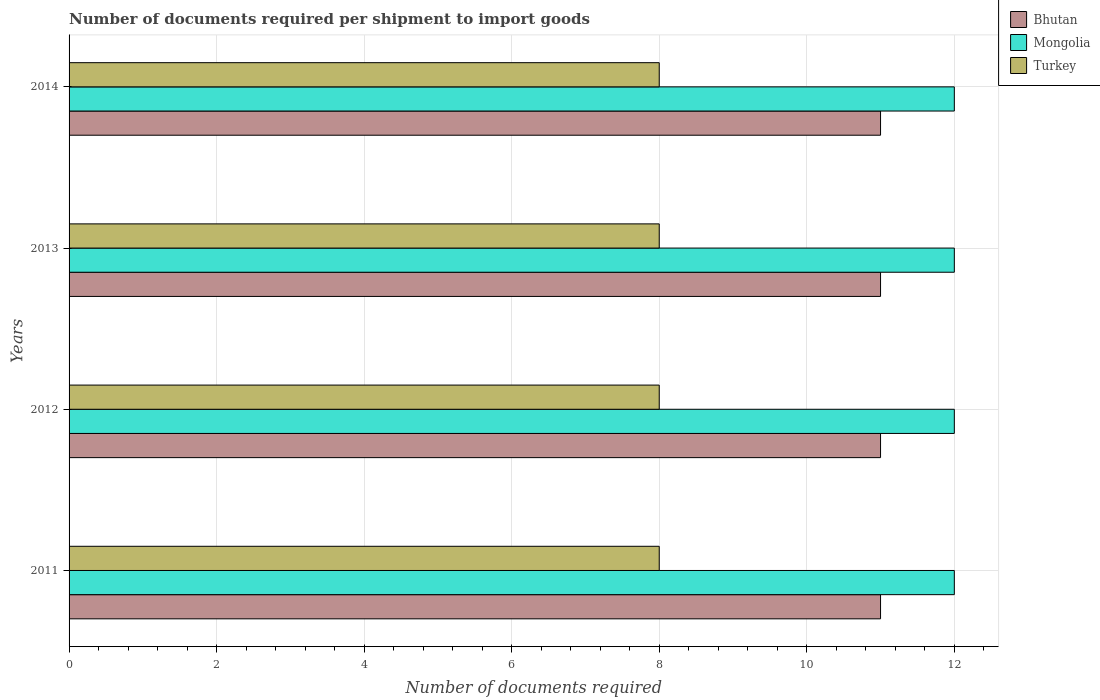How many groups of bars are there?
Keep it short and to the point. 4. Are the number of bars on each tick of the Y-axis equal?
Give a very brief answer. Yes. In how many cases, is the number of bars for a given year not equal to the number of legend labels?
Offer a very short reply. 0. What is the number of documents required per shipment to import goods in Turkey in 2012?
Provide a short and direct response. 8. Across all years, what is the maximum number of documents required per shipment to import goods in Bhutan?
Make the answer very short. 11. Across all years, what is the minimum number of documents required per shipment to import goods in Bhutan?
Give a very brief answer. 11. In which year was the number of documents required per shipment to import goods in Bhutan minimum?
Your answer should be compact. 2011. What is the total number of documents required per shipment to import goods in Bhutan in the graph?
Provide a short and direct response. 44. What is the difference between the number of documents required per shipment to import goods in Bhutan in 2013 and that in 2014?
Keep it short and to the point. 0. What is the difference between the number of documents required per shipment to import goods in Bhutan in 2014 and the number of documents required per shipment to import goods in Turkey in 2012?
Your answer should be compact. 3. In the year 2012, what is the difference between the number of documents required per shipment to import goods in Turkey and number of documents required per shipment to import goods in Bhutan?
Give a very brief answer. -3. In how many years, is the number of documents required per shipment to import goods in Turkey greater than 3.6 ?
Provide a short and direct response. 4. What is the ratio of the number of documents required per shipment to import goods in Bhutan in 2011 to that in 2012?
Provide a succinct answer. 1. Is the number of documents required per shipment to import goods in Mongolia in 2012 less than that in 2013?
Make the answer very short. No. What is the difference between the highest and the second highest number of documents required per shipment to import goods in Bhutan?
Your answer should be very brief. 0. In how many years, is the number of documents required per shipment to import goods in Mongolia greater than the average number of documents required per shipment to import goods in Mongolia taken over all years?
Ensure brevity in your answer.  0. What does the 1st bar from the top in 2014 represents?
Your response must be concise. Turkey. What does the 3rd bar from the bottom in 2012 represents?
Your response must be concise. Turkey. How many bars are there?
Provide a succinct answer. 12. What is the difference between two consecutive major ticks on the X-axis?
Offer a very short reply. 2. How many legend labels are there?
Provide a short and direct response. 3. How are the legend labels stacked?
Give a very brief answer. Vertical. What is the title of the graph?
Ensure brevity in your answer.  Number of documents required per shipment to import goods. Does "Macao" appear as one of the legend labels in the graph?
Ensure brevity in your answer.  No. What is the label or title of the X-axis?
Give a very brief answer. Number of documents required. What is the Number of documents required in Mongolia in 2011?
Your answer should be compact. 12. What is the Number of documents required in Bhutan in 2012?
Your answer should be very brief. 11. What is the Number of documents required of Mongolia in 2012?
Provide a succinct answer. 12. What is the Number of documents required of Turkey in 2012?
Keep it short and to the point. 8. What is the Number of documents required of Bhutan in 2013?
Keep it short and to the point. 11. What is the Number of documents required in Mongolia in 2013?
Provide a short and direct response. 12. What is the Number of documents required of Mongolia in 2014?
Ensure brevity in your answer.  12. Across all years, what is the maximum Number of documents required in Bhutan?
Provide a short and direct response. 11. Across all years, what is the maximum Number of documents required in Mongolia?
Offer a very short reply. 12. Across all years, what is the minimum Number of documents required in Bhutan?
Provide a succinct answer. 11. What is the total Number of documents required in Bhutan in the graph?
Ensure brevity in your answer.  44. What is the total Number of documents required of Turkey in the graph?
Give a very brief answer. 32. What is the difference between the Number of documents required in Mongolia in 2011 and that in 2012?
Make the answer very short. 0. What is the difference between the Number of documents required of Turkey in 2011 and that in 2012?
Offer a terse response. 0. What is the difference between the Number of documents required of Mongolia in 2011 and that in 2014?
Make the answer very short. 0. What is the difference between the Number of documents required of Turkey in 2011 and that in 2014?
Keep it short and to the point. 0. What is the difference between the Number of documents required of Bhutan in 2012 and that in 2013?
Your response must be concise. 0. What is the difference between the Number of documents required of Turkey in 2012 and that in 2013?
Your answer should be very brief. 0. What is the difference between the Number of documents required in Bhutan in 2012 and that in 2014?
Keep it short and to the point. 0. What is the difference between the Number of documents required of Turkey in 2012 and that in 2014?
Your response must be concise. 0. What is the difference between the Number of documents required in Bhutan in 2013 and that in 2014?
Provide a short and direct response. 0. What is the difference between the Number of documents required of Bhutan in 2011 and the Number of documents required of Mongolia in 2012?
Your answer should be very brief. -1. What is the difference between the Number of documents required of Bhutan in 2011 and the Number of documents required of Turkey in 2012?
Offer a terse response. 3. What is the difference between the Number of documents required in Bhutan in 2012 and the Number of documents required in Turkey in 2013?
Your answer should be compact. 3. What is the difference between the Number of documents required in Mongolia in 2012 and the Number of documents required in Turkey in 2013?
Provide a succinct answer. 4. What is the difference between the Number of documents required of Bhutan in 2012 and the Number of documents required of Mongolia in 2014?
Your response must be concise. -1. What is the difference between the Number of documents required in Bhutan in 2013 and the Number of documents required in Turkey in 2014?
Ensure brevity in your answer.  3. What is the average Number of documents required in Bhutan per year?
Provide a short and direct response. 11. What is the average Number of documents required of Turkey per year?
Offer a very short reply. 8. In the year 2012, what is the difference between the Number of documents required in Bhutan and Number of documents required in Mongolia?
Keep it short and to the point. -1. In the year 2012, what is the difference between the Number of documents required of Mongolia and Number of documents required of Turkey?
Your answer should be very brief. 4. In the year 2014, what is the difference between the Number of documents required of Bhutan and Number of documents required of Mongolia?
Your response must be concise. -1. In the year 2014, what is the difference between the Number of documents required of Mongolia and Number of documents required of Turkey?
Ensure brevity in your answer.  4. What is the ratio of the Number of documents required of Bhutan in 2011 to that in 2013?
Your answer should be very brief. 1. What is the ratio of the Number of documents required of Mongolia in 2011 to that in 2013?
Offer a very short reply. 1. What is the ratio of the Number of documents required in Turkey in 2011 to that in 2013?
Keep it short and to the point. 1. What is the ratio of the Number of documents required of Mongolia in 2011 to that in 2014?
Your answer should be very brief. 1. What is the ratio of the Number of documents required of Turkey in 2011 to that in 2014?
Give a very brief answer. 1. What is the ratio of the Number of documents required in Bhutan in 2012 to that in 2013?
Keep it short and to the point. 1. What is the ratio of the Number of documents required in Turkey in 2012 to that in 2013?
Your answer should be very brief. 1. What is the ratio of the Number of documents required of Bhutan in 2012 to that in 2014?
Offer a terse response. 1. What is the ratio of the Number of documents required in Turkey in 2012 to that in 2014?
Provide a short and direct response. 1. What is the ratio of the Number of documents required of Bhutan in 2013 to that in 2014?
Keep it short and to the point. 1. What is the ratio of the Number of documents required in Mongolia in 2013 to that in 2014?
Offer a terse response. 1. What is the ratio of the Number of documents required of Turkey in 2013 to that in 2014?
Provide a short and direct response. 1. What is the difference between the highest and the lowest Number of documents required in Bhutan?
Offer a very short reply. 0. What is the difference between the highest and the lowest Number of documents required in Mongolia?
Provide a short and direct response. 0. 